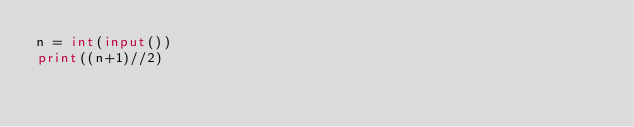<code> <loc_0><loc_0><loc_500><loc_500><_Python_>n = int(input())
print((n+1)//2)</code> 